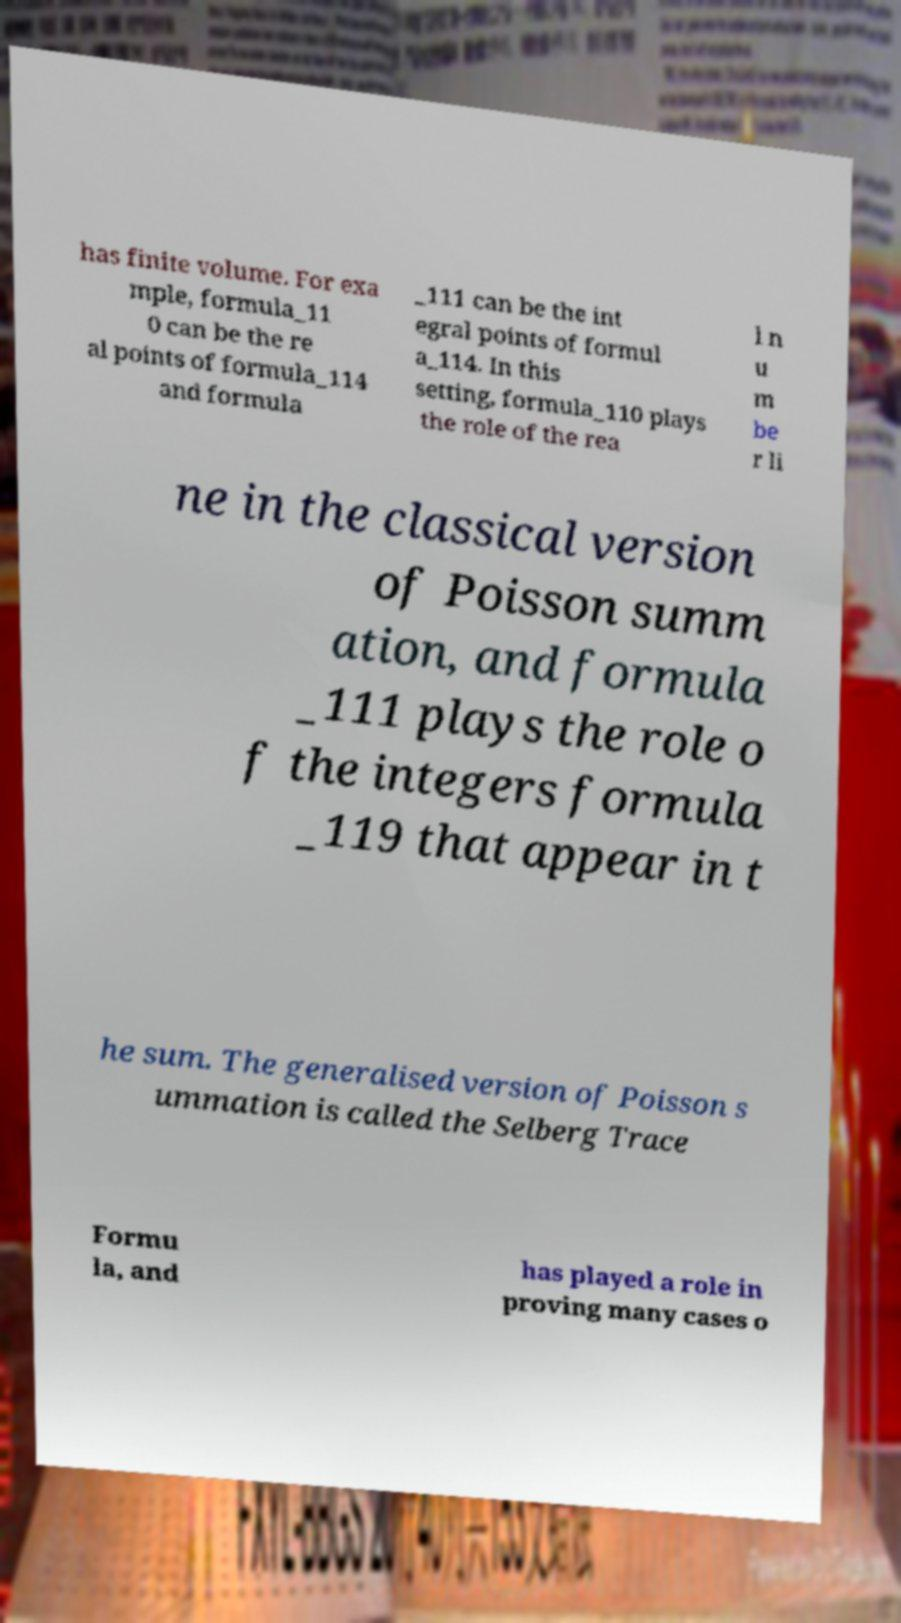Can you accurately transcribe the text from the provided image for me? has finite volume. For exa mple, formula_11 0 can be the re al points of formula_114 and formula _111 can be the int egral points of formul a_114. In this setting, formula_110 plays the role of the rea l n u m be r li ne in the classical version of Poisson summ ation, and formula _111 plays the role o f the integers formula _119 that appear in t he sum. The generalised version of Poisson s ummation is called the Selberg Trace Formu la, and has played a role in proving many cases o 